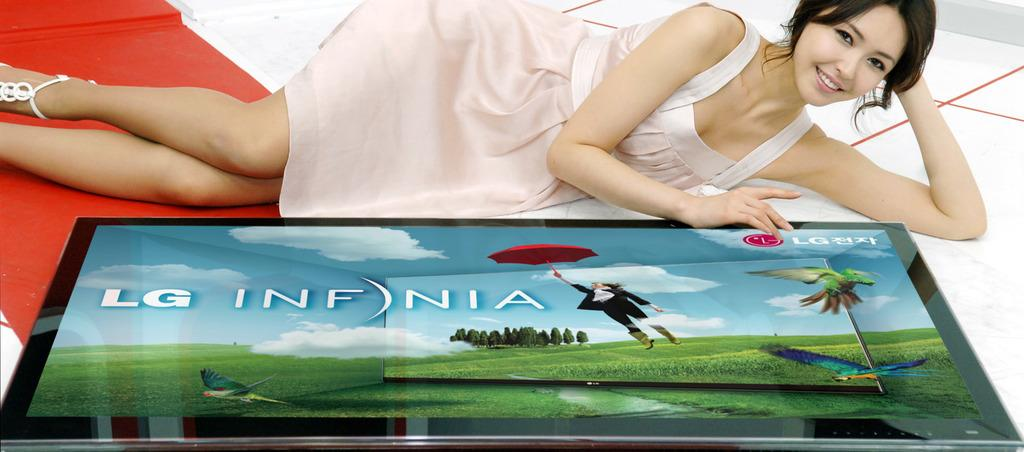What is the woman in the image doing? The woman is lying on the floor in the image. What electronic device can be seen in the image? There is a TV in the image. What color is the carpet on the left side of the image? The carpet on the left side of the image is red. How many fingers can be seen holding the vase in the image? There is no vase present in the image, so it is not possible to determine how many fingers might be holding it. 